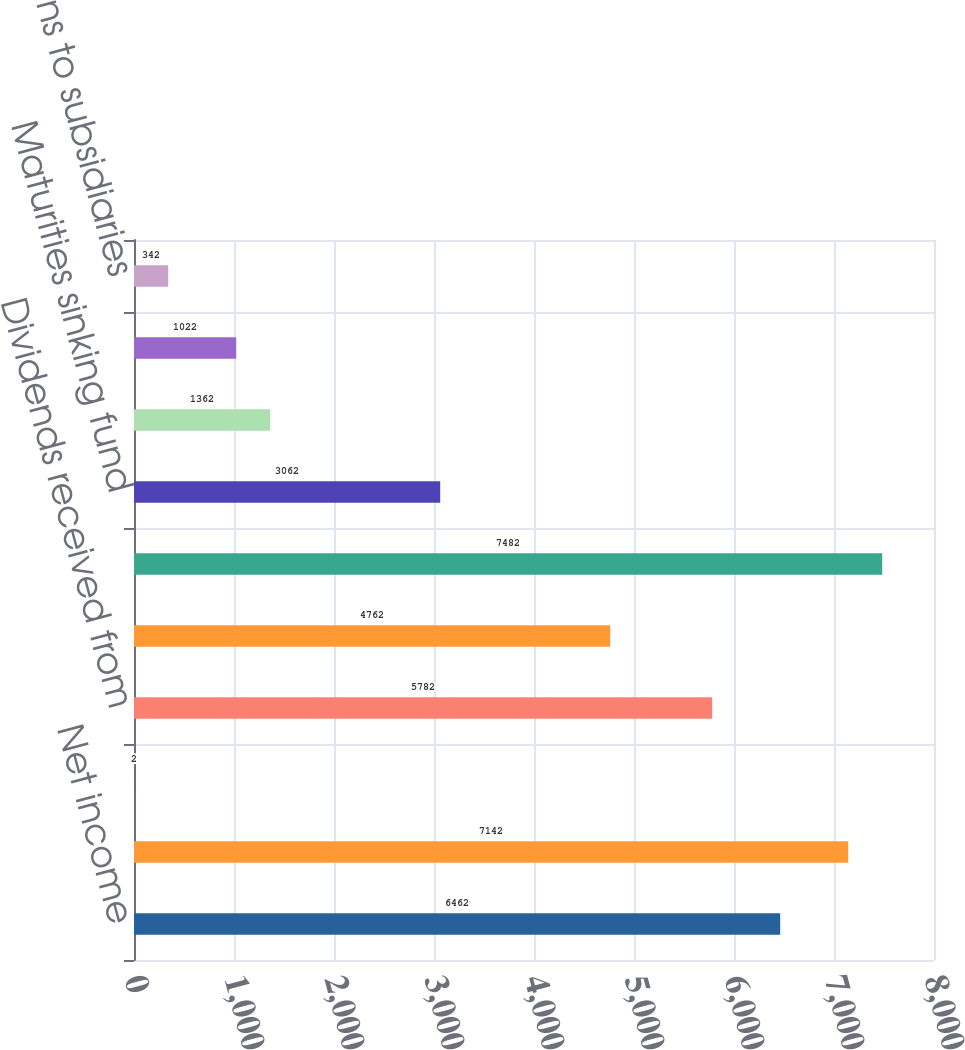Convert chart to OTSL. <chart><loc_0><loc_0><loc_500><loc_500><bar_chart><fcel>Net income<fcel>Equity in earnings of<fcel>Loss from discontinued<fcel>Dividends received from<fcel>Other operating activities<fcel>Net cash provided by operating<fcel>Maturities sinking fund<fcel>Purchase of other investments<fcel>Purchase of land buildings<fcel>Contributions to subsidiaries<nl><fcel>6462<fcel>7142<fcel>2<fcel>5782<fcel>4762<fcel>7482<fcel>3062<fcel>1362<fcel>1022<fcel>342<nl></chart> 